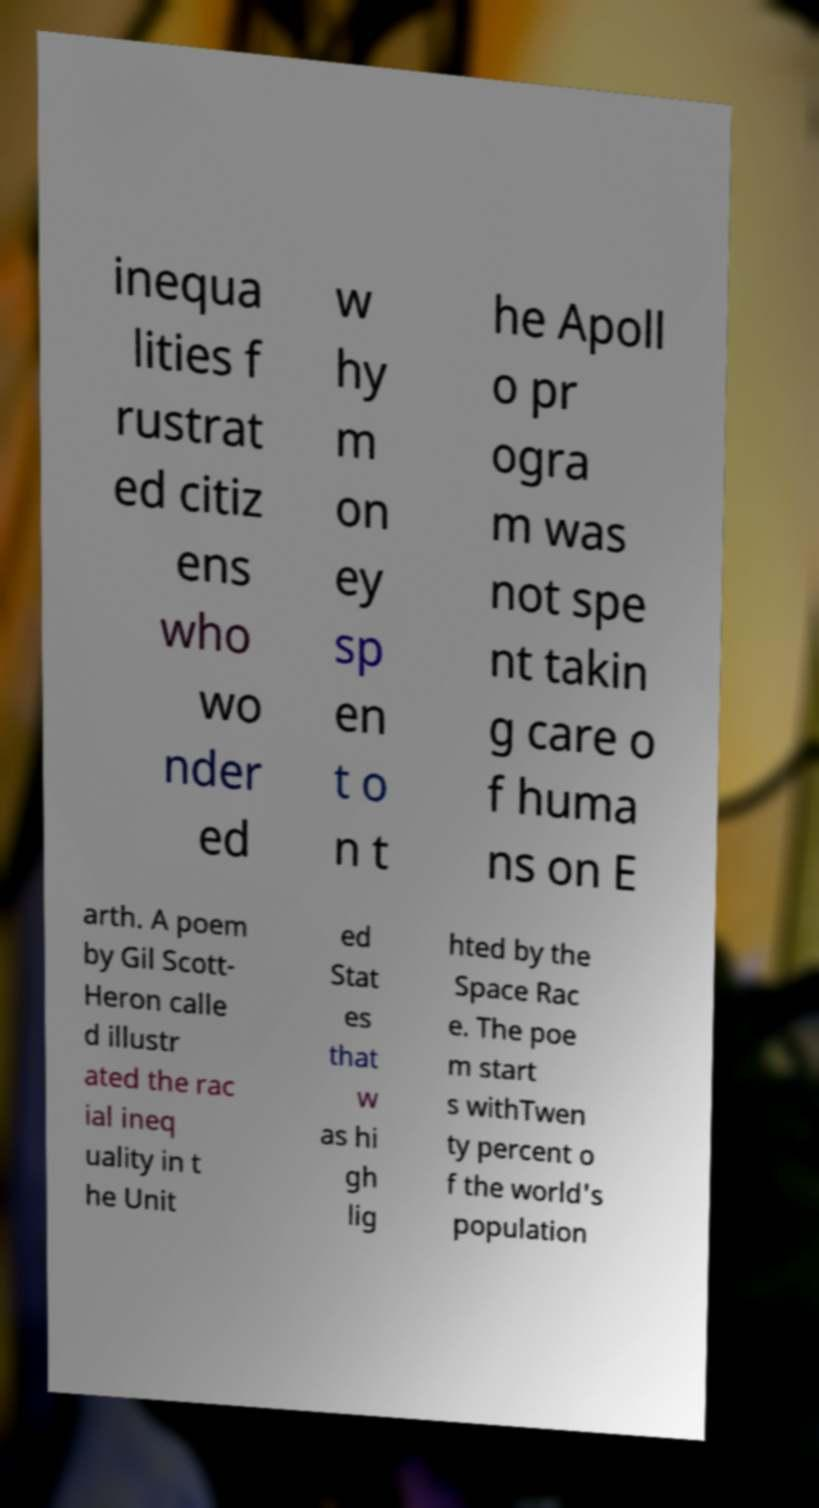Could you extract and type out the text from this image? inequa lities f rustrat ed citiz ens who wo nder ed w hy m on ey sp en t o n t he Apoll o pr ogra m was not spe nt takin g care o f huma ns on E arth. A poem by Gil Scott- Heron calle d illustr ated the rac ial ineq uality in t he Unit ed Stat es that w as hi gh lig hted by the Space Rac e. The poe m start s withTwen ty percent o f the world's population 